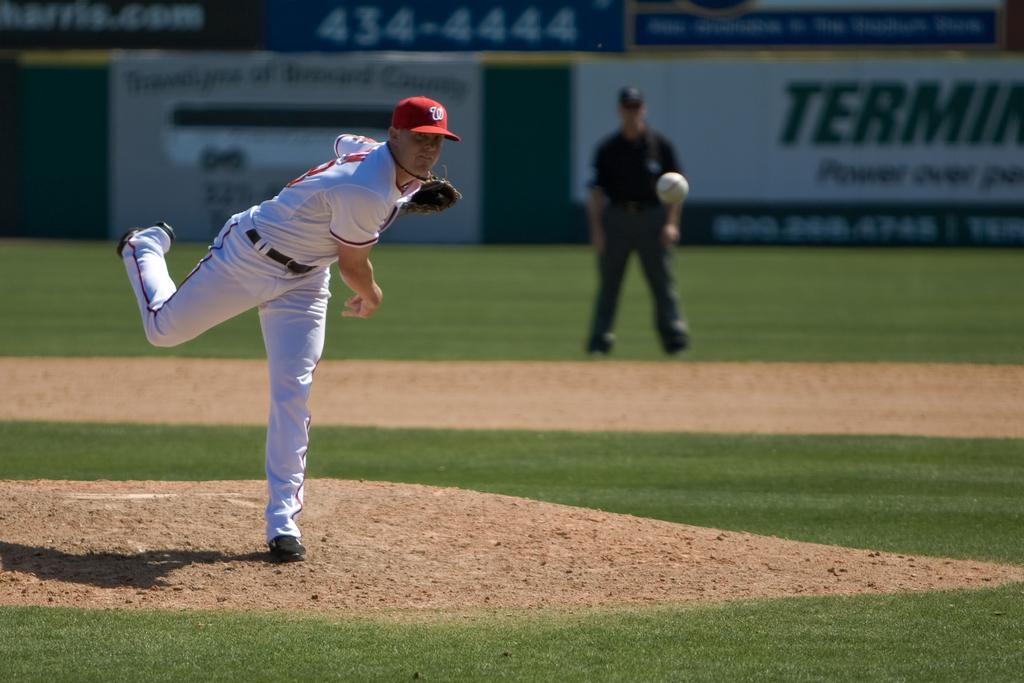<image>
Write a terse but informative summary of the picture. A baseball pitcher is throwing a ball on a field that has a Terminix banner in the background. 